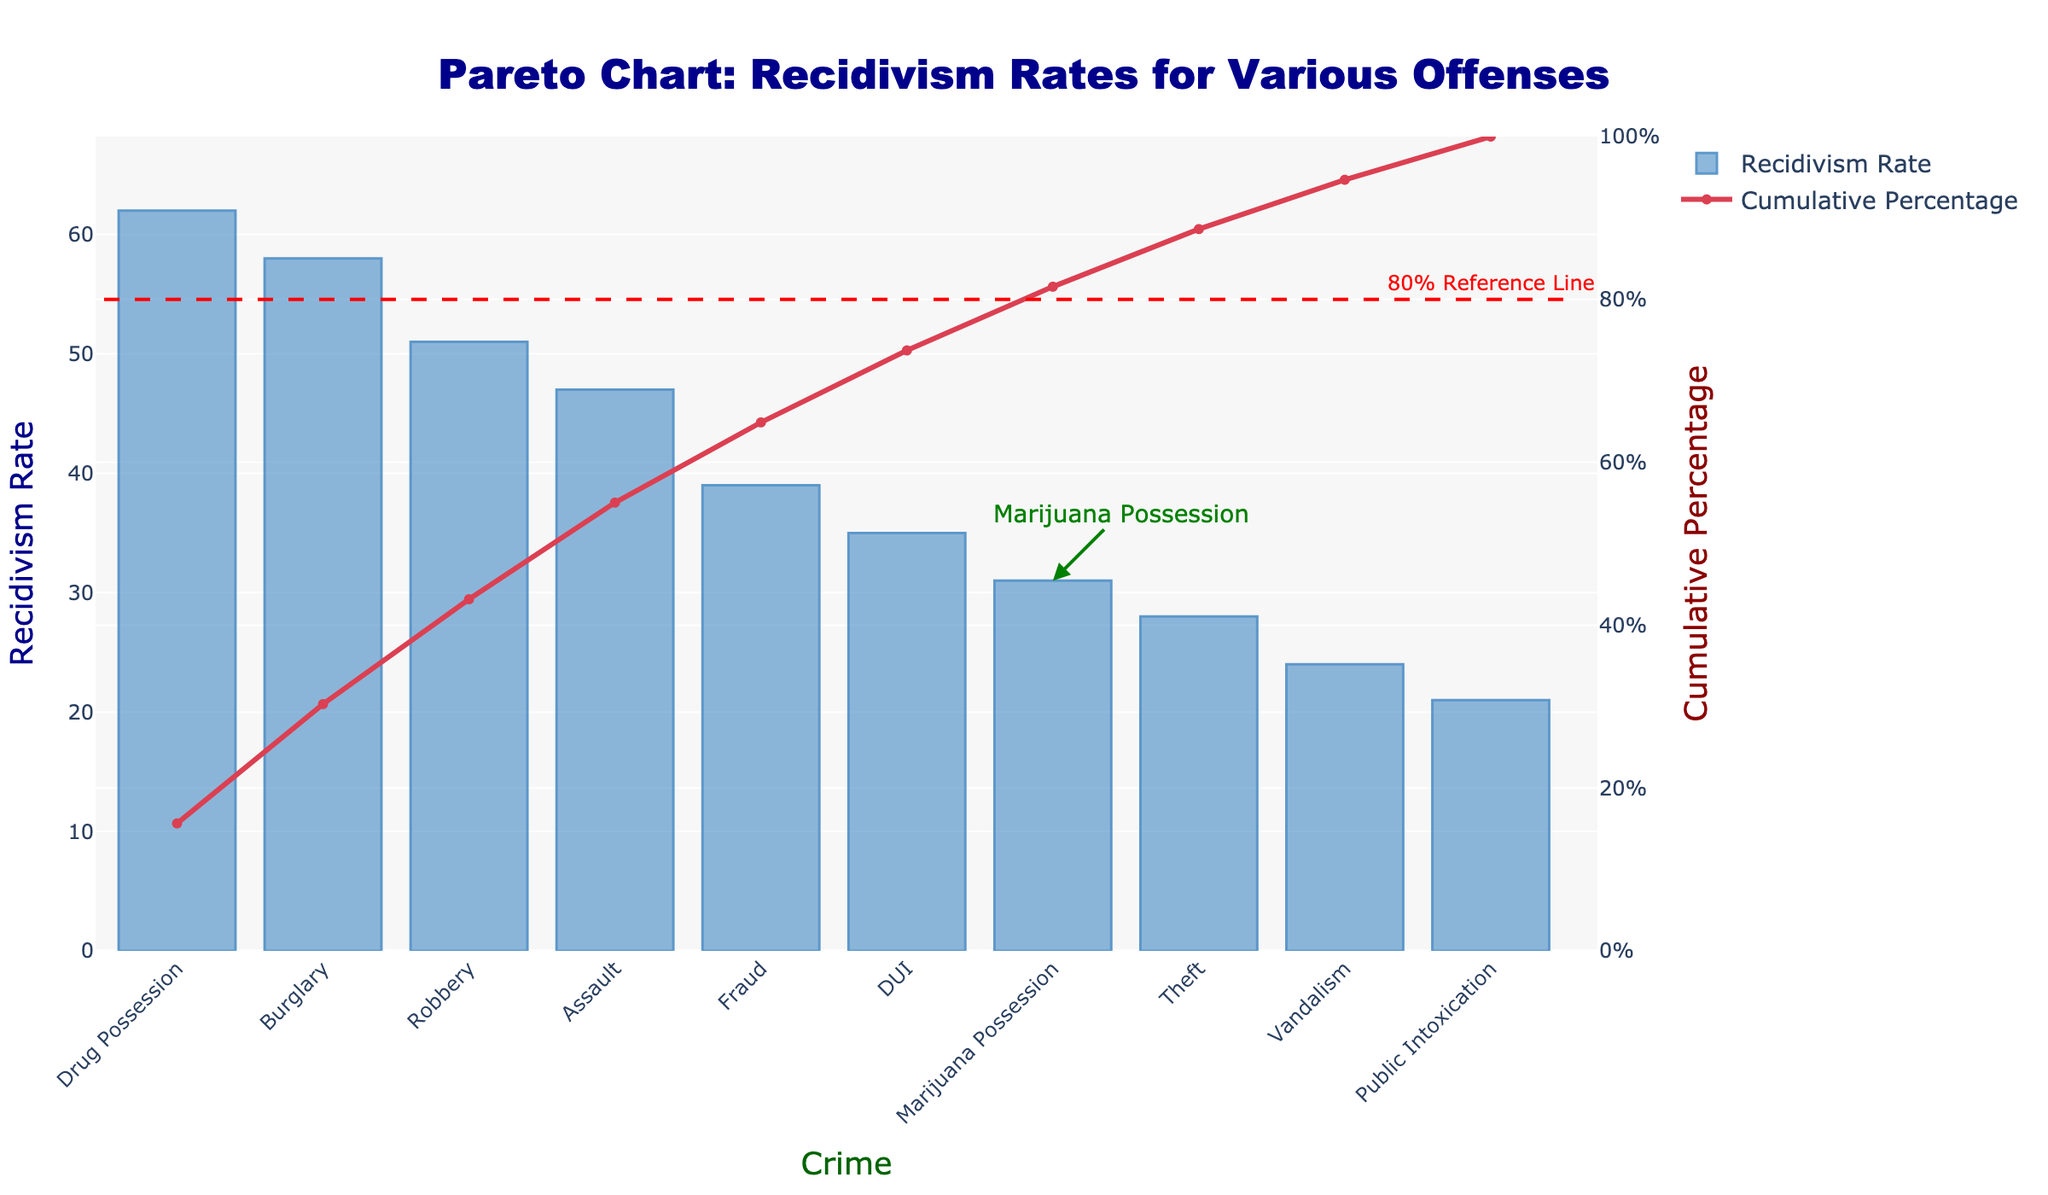What is the recidivism rate for Marijuana Possession? Find the bar labeled "Marijuana Possession" on the x-axis and read the height of the bar on the y-axis.
Answer: 31 Which crime has the highest recidivism rate? Look at the tallest bar in the chart and check the label on the x-axis.
Answer: Drug Possession What is the cumulative percentage when considering Marijuana Possession? Locate "Marijuana Possession" on the x-axis, and then find the corresponding value on the y2-axis (right y-axis).
Answer: Approximately 78% What is the title of the chart? Look at the text displayed at the top center of the chart.
Answer: Pareto Chart: Recidivism Rates for Various Offenses How does the recidivism rate for Assault compare to the rate for Marijuana Possession? Find both "Assault" and "Marijuana Possession" bars on the x-axis and compare their heights on the y-axis.
Answer: Higher What is the purpose of the red dashed line in the chart? Observe the labeled annotation near the red dashed line; it indicates its purpose.
Answer: 80% Reference Line What is the color of the bar representing Robbery? Observe the color scheme used for the bars and match the bar labeled as "Robbery."
Answer: Blue How many crimes have a recidivism rate greater than 50%? Count the number of bars that exceed the 50% mark on the y-axis.
Answer: 3 What's the cumulative percentage after considering all offenses? Look at the final point on the cumulative percentage line on the y2-axis.
Answer: 100% Which crime has the lowest recidivism rate? Find the shortest bar in the chart and check the label on the x-axis.
Answer: Public Intoxication 